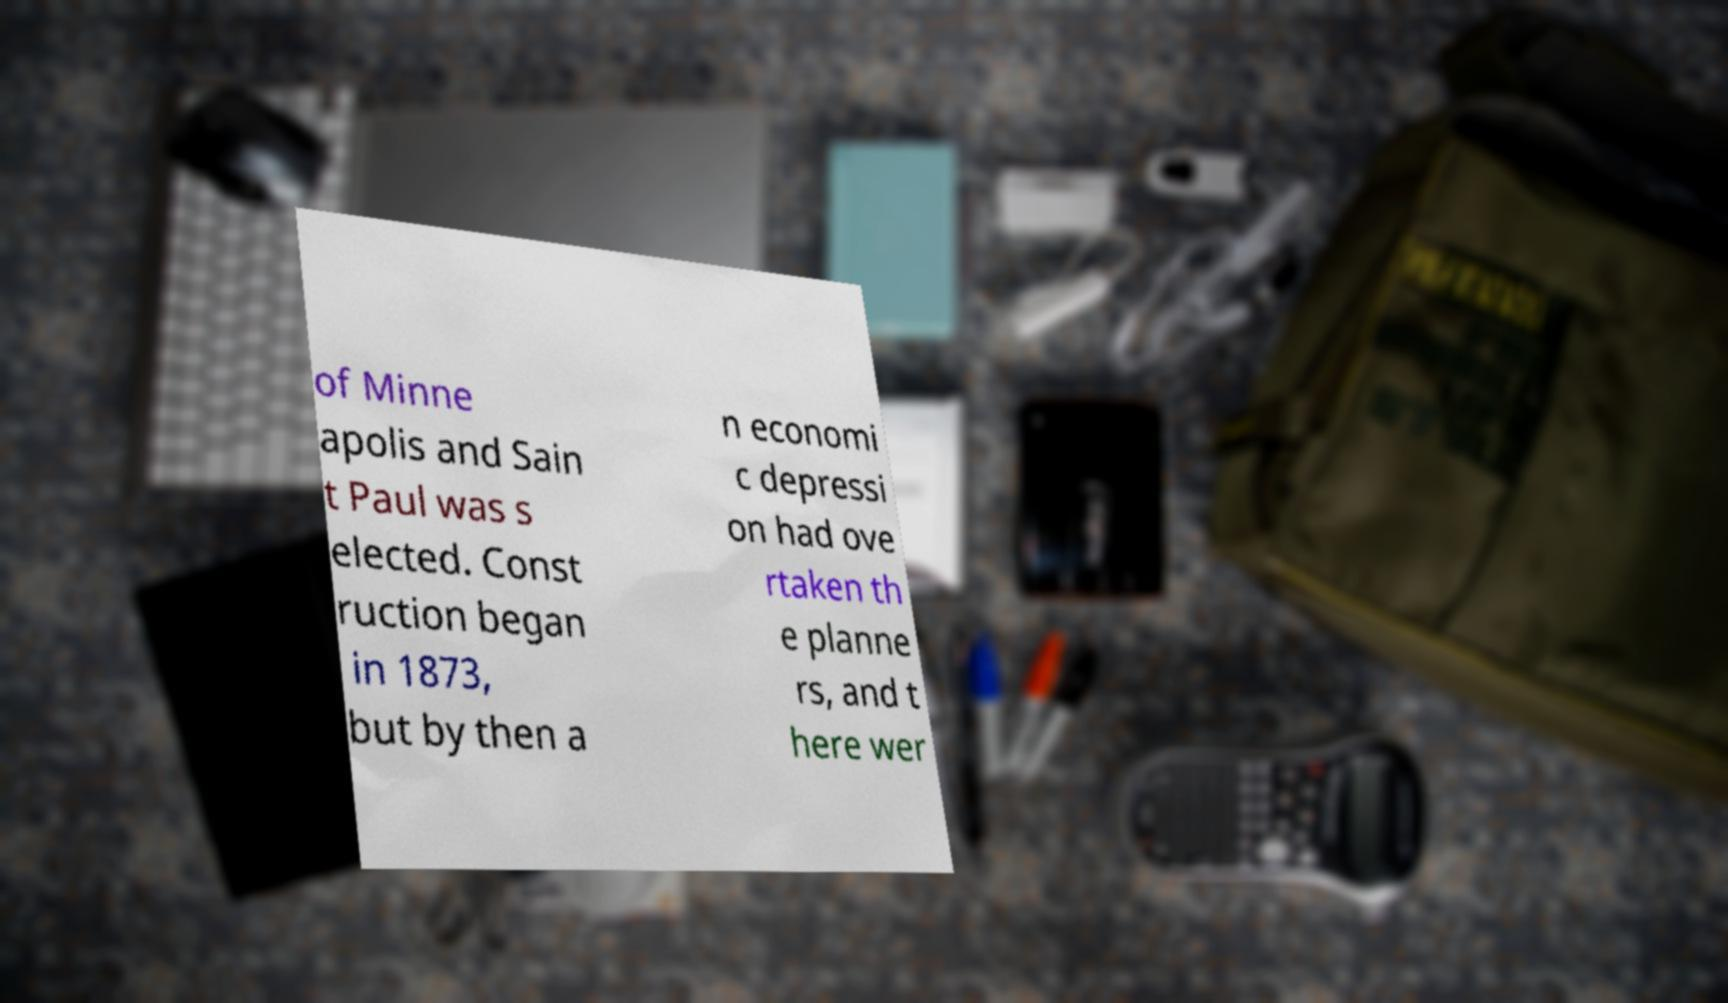Could you extract and type out the text from this image? of Minne apolis and Sain t Paul was s elected. Const ruction began in 1873, but by then a n economi c depressi on had ove rtaken th e planne rs, and t here wer 